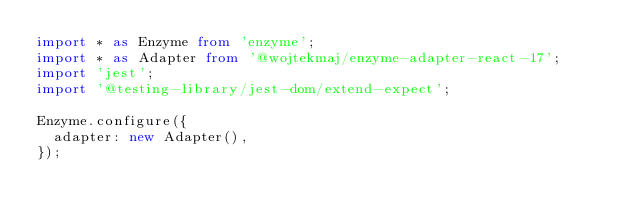<code> <loc_0><loc_0><loc_500><loc_500><_TypeScript_>import * as Enzyme from 'enzyme';
import * as Adapter from '@wojtekmaj/enzyme-adapter-react-17';
import 'jest';
import '@testing-library/jest-dom/extend-expect';

Enzyme.configure({
  adapter: new Adapter(),
});
</code> 